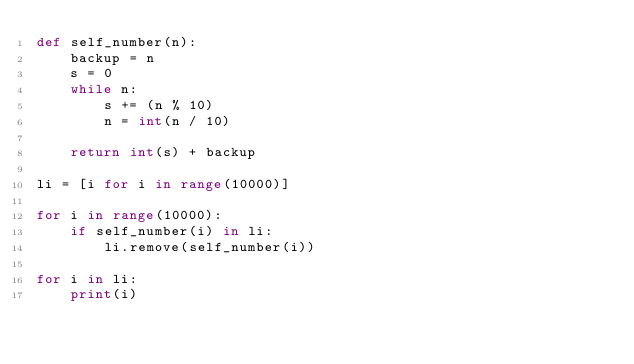<code> <loc_0><loc_0><loc_500><loc_500><_Python_>def self_number(n):
    backup = n
    s = 0
    while n:
        s += (n % 10)
        n = int(n / 10)

    return int(s) + backup

li = [i for i in range(10000)]

for i in range(10000):
    if self_number(i) in li:
        li.remove(self_number(i))

for i in li:
    print(i)
</code> 